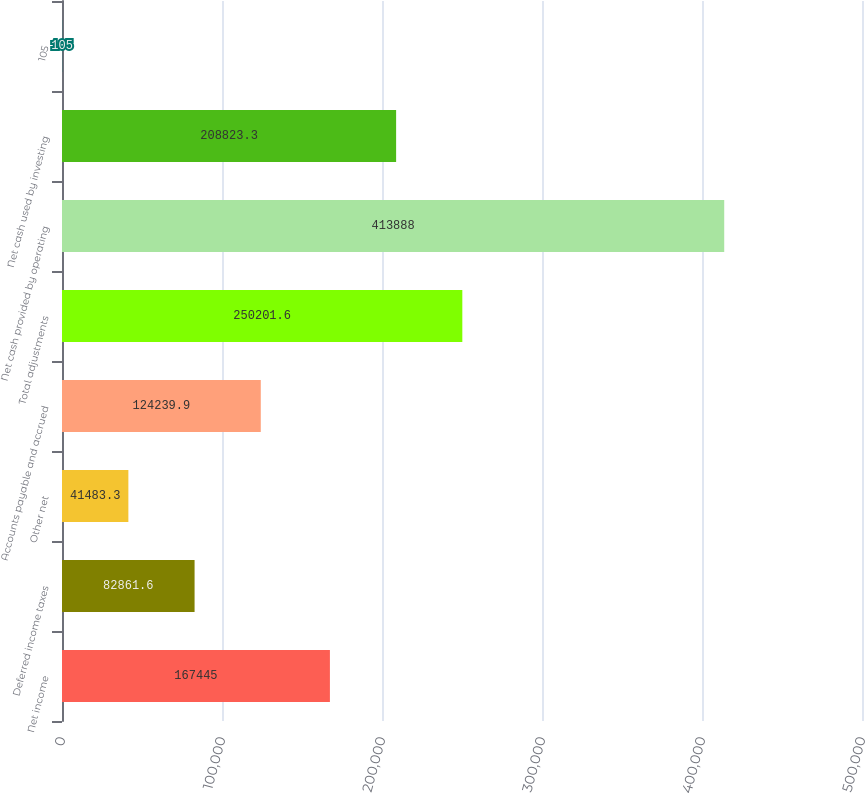Convert chart to OTSL. <chart><loc_0><loc_0><loc_500><loc_500><bar_chart><fcel>Net income<fcel>Deferred income taxes<fcel>Other net<fcel>Accounts payable and accrued<fcel>Total adjustments<fcel>Net cash provided by operating<fcel>Net cash used by investing<fcel>105<nl><fcel>167445<fcel>82861.6<fcel>41483.3<fcel>124240<fcel>250202<fcel>413888<fcel>208823<fcel>105<nl></chart> 